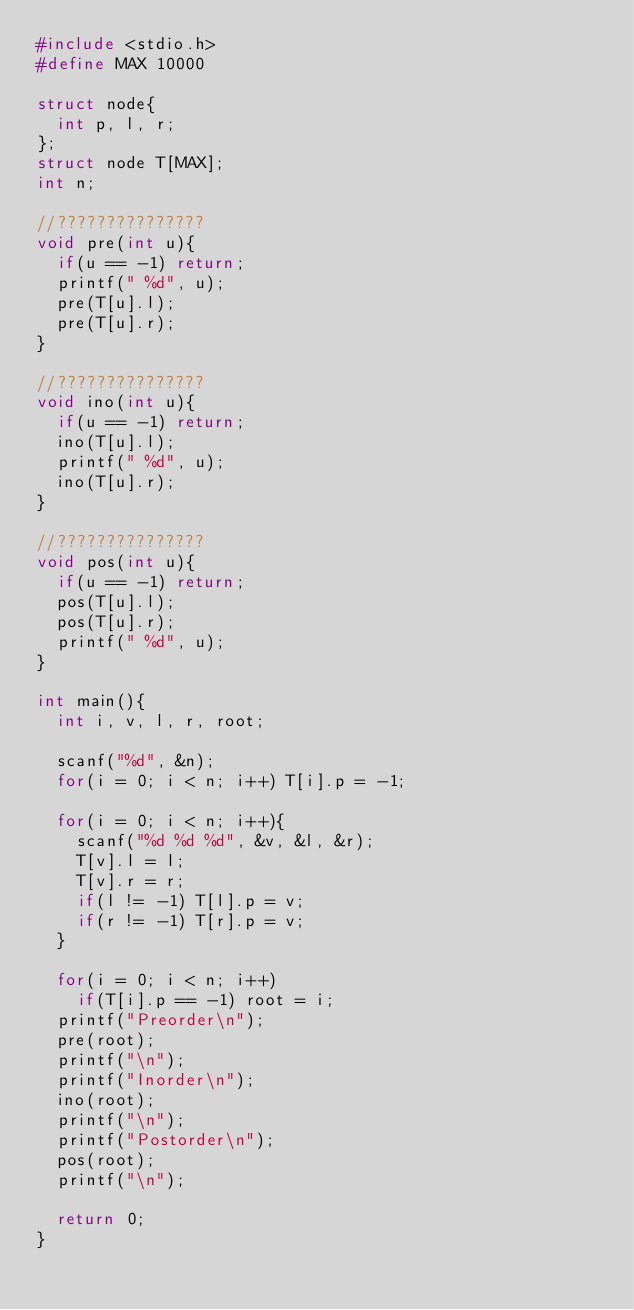Convert code to text. <code><loc_0><loc_0><loc_500><loc_500><_C_>#include <stdio.h>
#define MAX 10000

struct node{
  int p, l, r;
};
struct node T[MAX];
int n;

//???????????????
void pre(int u){
  if(u == -1) return;
  printf(" %d", u);
  pre(T[u].l);
  pre(T[u].r);
}

//???????????????
void ino(int u){
  if(u == -1) return;
  ino(T[u].l);
  printf(" %d", u);
  ino(T[u].r);
}

//???????????????
void pos(int u){
  if(u == -1) return;
  pos(T[u].l);
  pos(T[u].r);
  printf(" %d", u);
}

int main(){
  int i, v, l, r, root;

  scanf("%d", &n);
  for(i = 0; i < n; i++) T[i].p = -1;

  for(i = 0; i < n; i++){
    scanf("%d %d %d", &v, &l, &r);
    T[v].l = l;
    T[v].r = r;
    if(l != -1) T[l].p = v;
    if(r != -1) T[r].p = v;
  }

  for(i = 0; i < n; i++)
    if(T[i].p == -1) root = i;
  printf("Preorder\n");
  pre(root);
  printf("\n");
  printf("Inorder\n");
  ino(root);
  printf("\n");
  printf("Postorder\n");
  pos(root);
  printf("\n");

  return 0;
}</code> 